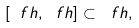<formula> <loc_0><loc_0><loc_500><loc_500>[ \ f h , \ f h ] \subset \ f h ,</formula> 